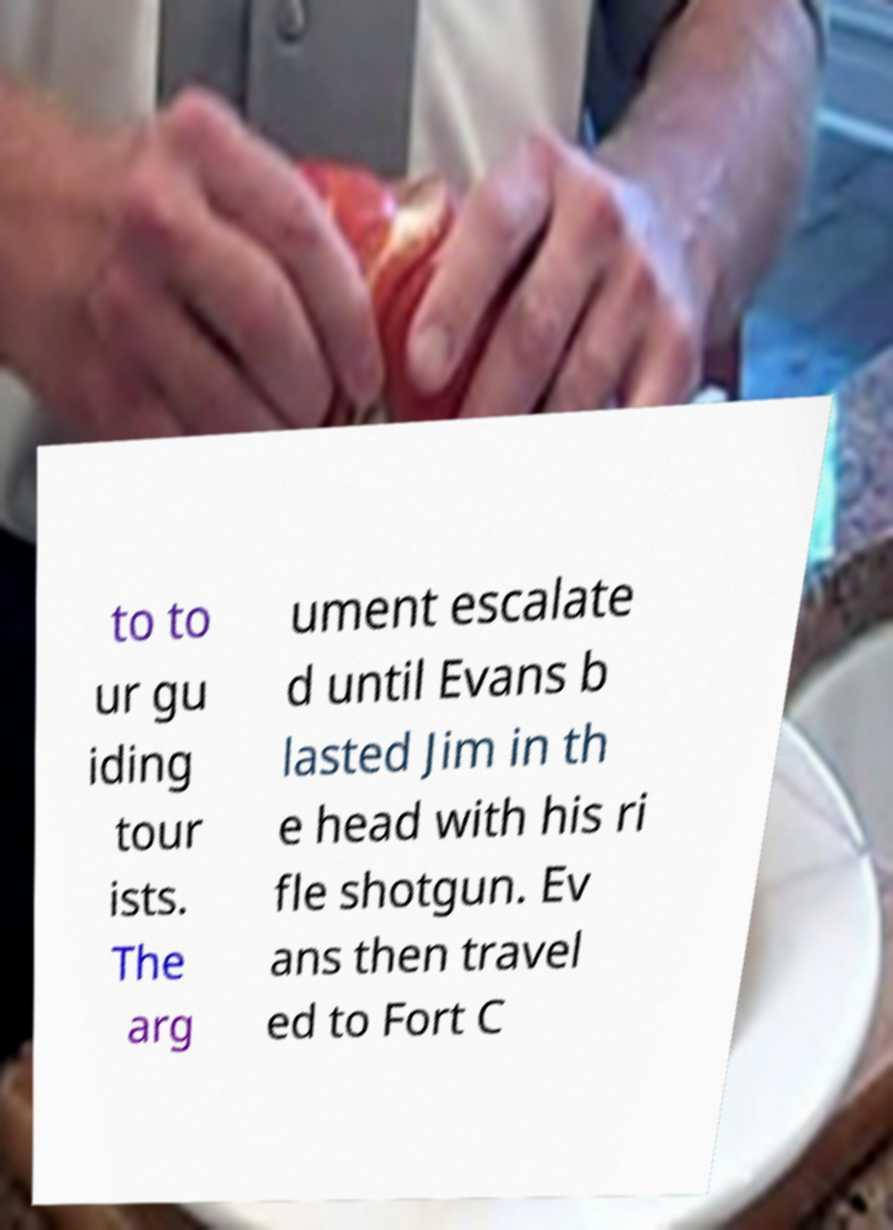Can you read and provide the text displayed in the image?This photo seems to have some interesting text. Can you extract and type it out for me? to to ur gu iding tour ists. The arg ument escalate d until Evans b lasted Jim in th e head with his ri fle shotgun. Ev ans then travel ed to Fort C 